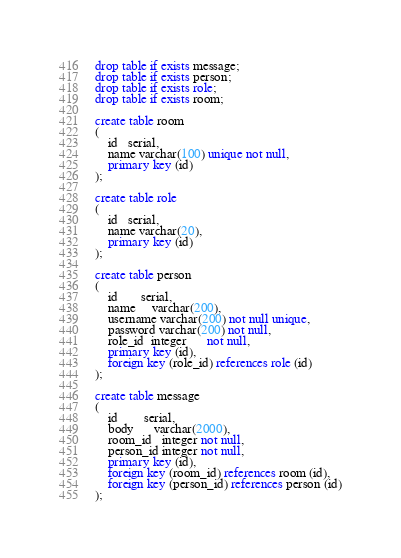<code> <loc_0><loc_0><loc_500><loc_500><_SQL_>drop table if exists message;
drop table if exists person;
drop table if exists role;
drop table if exists room;

create table room
(
    id   serial,
    name varchar(100) unique not null,
    primary key (id)
);

create table role
(
    id   serial,
    name varchar(20),
    primary key (id)
);

create table person
(
    id       serial,
    name     varchar(200),
    username varchar(200) not null unique,
    password varchar(200) not null,
    role_id  integer      not null,
    primary key (id),
    foreign key (role_id) references role (id)
);

create table message
(
    id        serial,
    body      varchar(2000),
    room_id   integer not null,
    person_id integer not null,
    primary key (id),
    foreign key (room_id) references room (id),
    foreign key (person_id) references person (id)
);</code> 